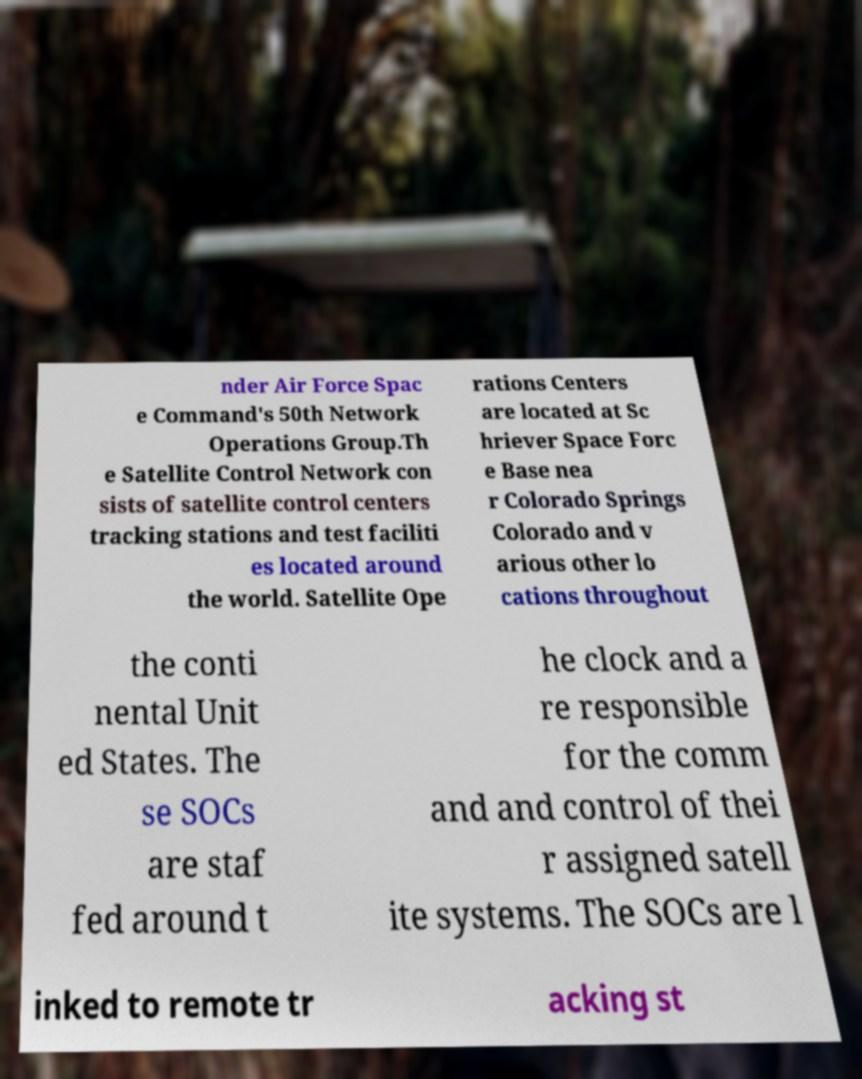For documentation purposes, I need the text within this image transcribed. Could you provide that? nder Air Force Spac e Command's 50th Network Operations Group.Th e Satellite Control Network con sists of satellite control centers tracking stations and test faciliti es located around the world. Satellite Ope rations Centers are located at Sc hriever Space Forc e Base nea r Colorado Springs Colorado and v arious other lo cations throughout the conti nental Unit ed States. The se SOCs are staf fed around t he clock and a re responsible for the comm and and control of thei r assigned satell ite systems. The SOCs are l inked to remote tr acking st 